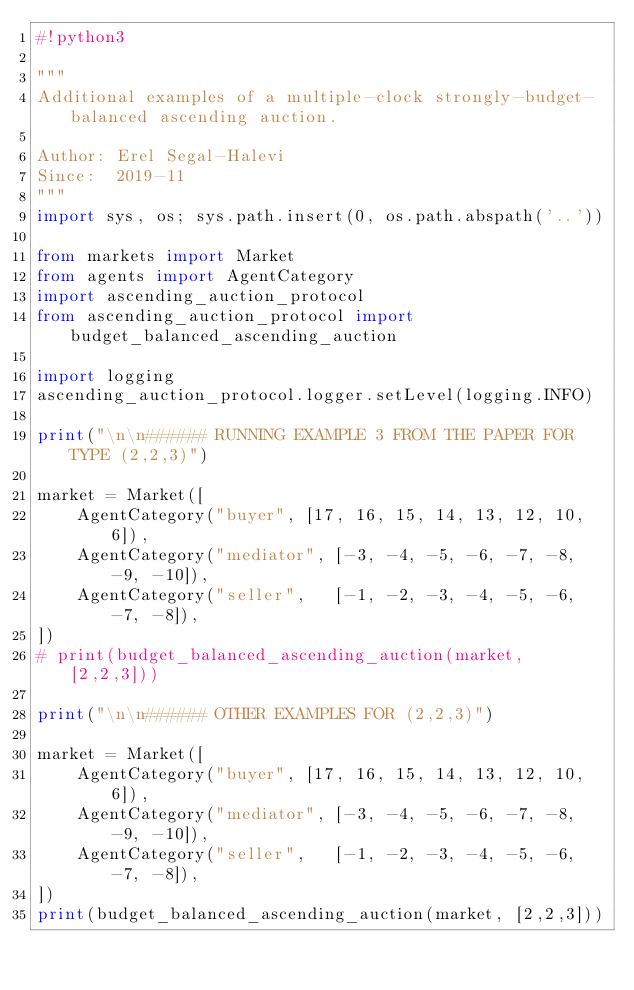Convert code to text. <code><loc_0><loc_0><loc_500><loc_500><_Python_>#!python3

"""
Additional examples of a multiple-clock strongly-budget-balanced ascending auction.

Author: Erel Segal-Halevi
Since:  2019-11
"""
import sys, os; sys.path.insert(0, os.path.abspath('..'))

from markets import Market
from agents import AgentCategory
import ascending_auction_protocol
from ascending_auction_protocol import budget_balanced_ascending_auction

import logging
ascending_auction_protocol.logger.setLevel(logging.INFO)

print("\n\n###### RUNNING EXAMPLE 3 FROM THE PAPER FOR TYPE (2,2,3)")

market = Market([
    AgentCategory("buyer", [17, 16, 15, 14, 13, 12, 10, 6]),
    AgentCategory("mediator", [-3, -4, -5, -6, -7, -8, -9, -10]),
    AgentCategory("seller",   [-1, -2, -3, -4, -5, -6, -7, -8]),
])
# print(budget_balanced_ascending_auction(market, [2,2,3]))

print("\n\n###### OTHER EXAMPLES FOR (2,2,3)")

market = Market([
    AgentCategory("buyer", [17, 16, 15, 14, 13, 12, 10, 6]),
    AgentCategory("mediator", [-3, -4, -5, -6, -7, -8, -9, -10]),
    AgentCategory("seller",   [-1, -2, -3, -4, -5, -6, -7, -8]),
])
print(budget_balanced_ascending_auction(market, [2,2,3]))
</code> 